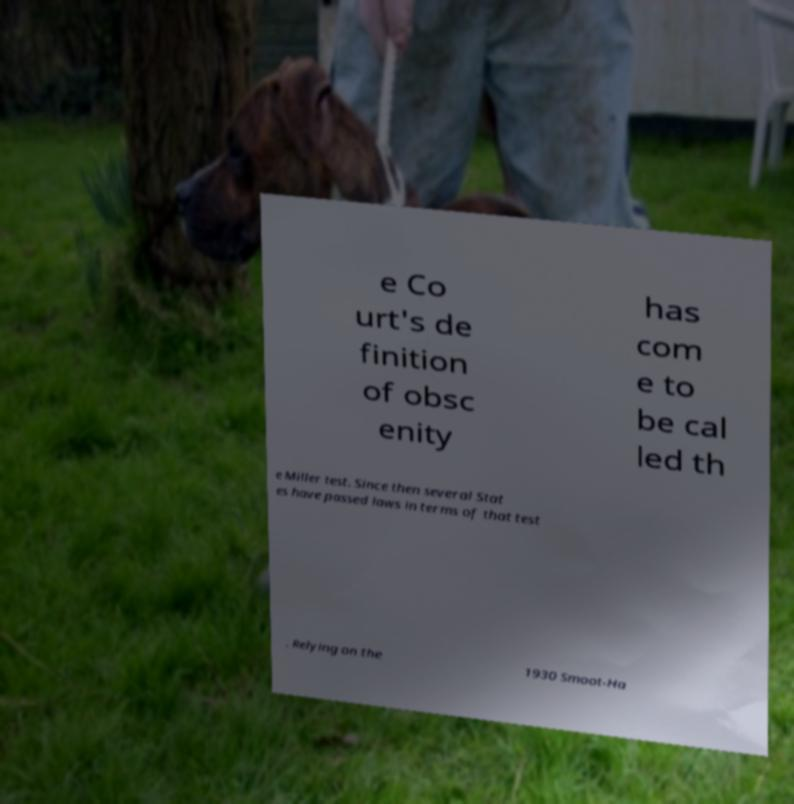For documentation purposes, I need the text within this image transcribed. Could you provide that? e Co urt's de finition of obsc enity has com e to be cal led th e Miller test. Since then several Stat es have passed laws in terms of that test . Relying on the 1930 Smoot-Ha 